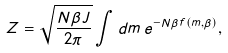<formula> <loc_0><loc_0><loc_500><loc_500>Z = \sqrt { \frac { N \beta J } { 2 \pi } } \int d m \, e ^ { - N \beta f ( m , \beta ) } ,</formula> 